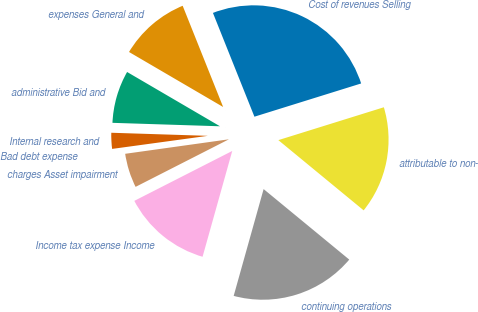Convert chart. <chart><loc_0><loc_0><loc_500><loc_500><pie_chart><fcel>Cost of revenues Selling<fcel>expenses General and<fcel>administrative Bid and<fcel>Internal research and<fcel>Bad debt expense<fcel>charges Asset impairment<fcel>Income tax expense Income<fcel>continuing operations<fcel>attributable to non-<nl><fcel>26.25%<fcel>10.53%<fcel>7.91%<fcel>2.67%<fcel>0.05%<fcel>5.29%<fcel>13.15%<fcel>18.39%<fcel>15.77%<nl></chart> 